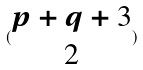<formula> <loc_0><loc_0><loc_500><loc_500>( \begin{matrix} p + q + 3 \\ 2 \end{matrix} )</formula> 